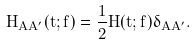<formula> <loc_0><loc_0><loc_500><loc_500>H _ { A A ^ { \prime } } ( t ; f ) = \frac { 1 } { 2 } H ( t ; f ) \delta _ { A A ^ { \prime } } .</formula> 